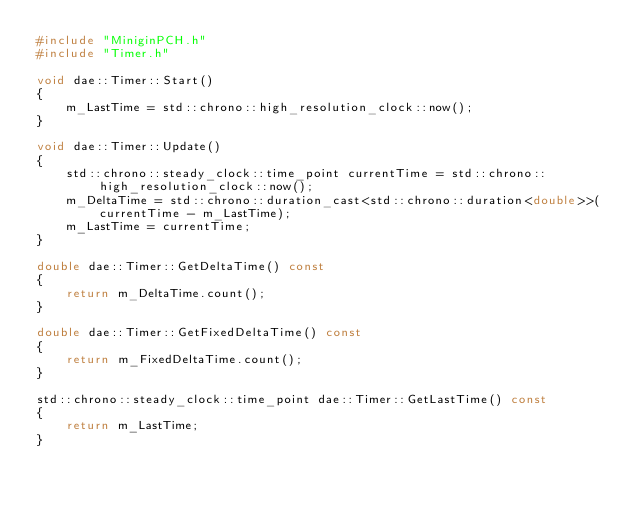<code> <loc_0><loc_0><loc_500><loc_500><_C++_>#include "MiniginPCH.h"
#include "Timer.h"

void dae::Timer::Start()
{
	m_LastTime = std::chrono::high_resolution_clock::now();
}

void dae::Timer::Update()
{
	std::chrono::steady_clock::time_point currentTime = std::chrono::high_resolution_clock::now();
	m_DeltaTime = std::chrono::duration_cast<std::chrono::duration<double>>(currentTime - m_LastTime);
	m_LastTime = currentTime;
}

double dae::Timer::GetDeltaTime() const
{
	return m_DeltaTime.count();
}

double dae::Timer::GetFixedDeltaTime() const
{
	return m_FixedDeltaTime.count();
}

std::chrono::steady_clock::time_point dae::Timer::GetLastTime() const
{
	return m_LastTime;
}

</code> 